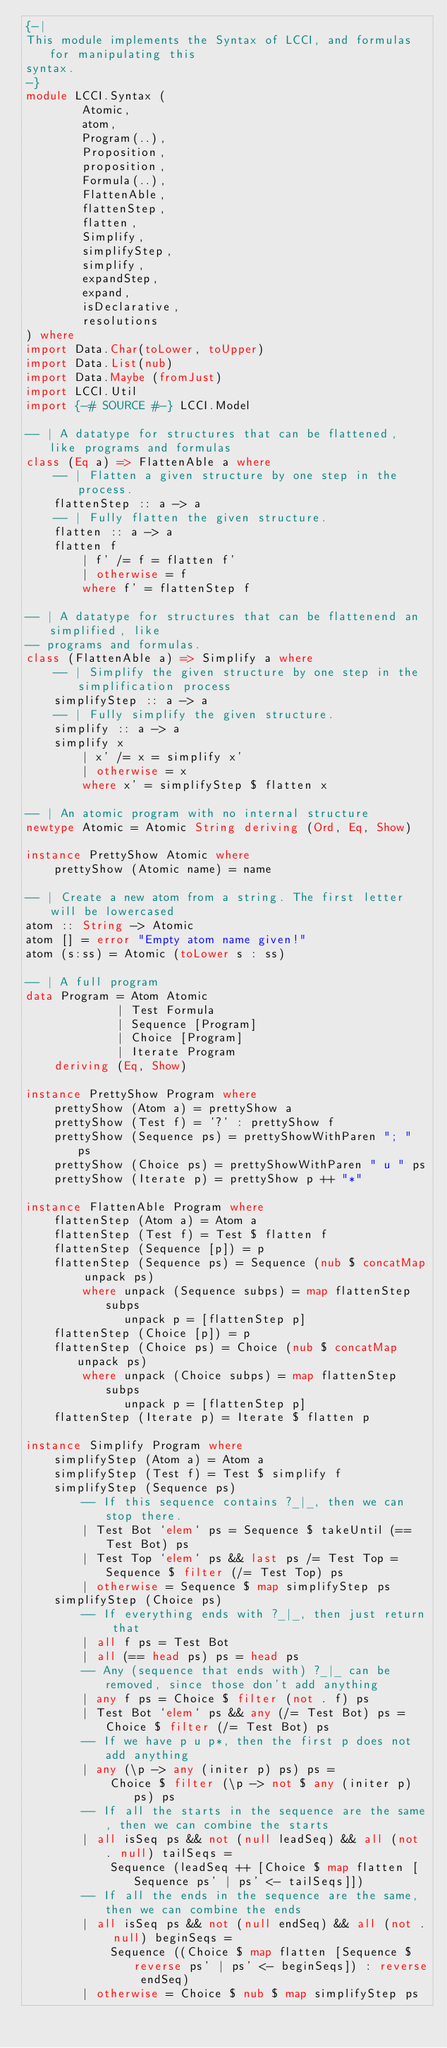Convert code to text. <code><loc_0><loc_0><loc_500><loc_500><_Haskell_>{-|
This module implements the Syntax of LCCI, and formulas for manipulating this
syntax.
-}
module LCCI.Syntax (
        Atomic,
        atom,
        Program(..),
        Proposition,
        proposition,
        Formula(..),
        FlattenAble,
        flattenStep,
        flatten,
        Simplify,
        simplifyStep,
        simplify,
        expandStep,
        expand,
        isDeclarative,
        resolutions
) where
import Data.Char(toLower, toUpper)
import Data.List(nub)
import Data.Maybe (fromJust)
import LCCI.Util
import {-# SOURCE #-} LCCI.Model

-- | A datatype for structures that can be flattened, like programs and formulas
class (Eq a) => FlattenAble a where
    -- | Flatten a given structure by one step in the process.
    flattenStep :: a -> a
    -- | Fully flatten the given structure.
    flatten :: a -> a
    flatten f
        | f' /= f = flatten f'
        | otherwise = f
        where f' = flattenStep f

-- | A datatype for structures that can be flattenend an simplified, like
-- programs and formulas.
class (FlattenAble a) => Simplify a where
    -- | Simplify the given structure by one step in the simplification process
    simplifyStep :: a -> a
    -- | Fully simplify the given structure.
    simplify :: a -> a
    simplify x
        | x' /= x = simplify x'
        | otherwise = x
        where x' = simplifyStep $ flatten x

-- | An atomic program with no internal structure
newtype Atomic = Atomic String deriving (Ord, Eq, Show)

instance PrettyShow Atomic where
    prettyShow (Atomic name) = name

-- | Create a new atom from a string. The first letter will be lowercased
atom :: String -> Atomic
atom [] = error "Empty atom name given!"
atom (s:ss) = Atomic (toLower s : ss)

-- | A full program
data Program = Atom Atomic
             | Test Formula
             | Sequence [Program]
             | Choice [Program]
             | Iterate Program
    deriving (Eq, Show)

instance PrettyShow Program where
    prettyShow (Atom a) = prettyShow a
    prettyShow (Test f) = '?' : prettyShow f
    prettyShow (Sequence ps) = prettyShowWithParen "; " ps
    prettyShow (Choice ps) = prettyShowWithParen " u " ps
    prettyShow (Iterate p) = prettyShow p ++ "*"

instance FlattenAble Program where
    flattenStep (Atom a) = Atom a
    flattenStep (Test f) = Test $ flatten f
    flattenStep (Sequence [p]) = p
    flattenStep (Sequence ps) = Sequence (nub $ concatMap unpack ps)
        where unpack (Sequence subps) = map flattenStep subps
              unpack p = [flattenStep p]
    flattenStep (Choice [p]) = p
    flattenStep (Choice ps) = Choice (nub $ concatMap unpack ps)
        where unpack (Choice subps) = map flattenStep subps
              unpack p = [flattenStep p]
    flattenStep (Iterate p) = Iterate $ flatten p

instance Simplify Program where
    simplifyStep (Atom a) = Atom a
    simplifyStep (Test f) = Test $ simplify f
    simplifyStep (Sequence ps)
        -- If this sequence contains ?_|_, then we can stop there.
        | Test Bot `elem` ps = Sequence $ takeUntil (== Test Bot) ps
        | Test Top `elem` ps && last ps /= Test Top = Sequence $ filter (/= Test Top) ps
        | otherwise = Sequence $ map simplifyStep ps
    simplifyStep (Choice ps)
        -- If everything ends with ?_|_, then just return that
        | all f ps = Test Bot
        | all (== head ps) ps = head ps
        -- Any (sequence that ends with) ?_|_ can be removed, since those don't add anything
        | any f ps = Choice $ filter (not . f) ps
        | Test Bot `elem` ps && any (/= Test Bot) ps = Choice $ filter (/= Test Bot) ps
        -- If we have p u p*, then the first p does not add anything
        | any (\p -> any (initer p) ps) ps =
            Choice $ filter (\p -> not $ any (initer p) ps) ps
        -- If all the starts in the sequence are the same, then we can combine the starts
        | all isSeq ps && not (null leadSeq) && all (not . null) tailSeqs =
            Sequence (leadSeq ++ [Choice $ map flatten [Sequence ps' | ps' <- tailSeqs]])
        -- If all the ends in the sequence are the same, then we can combine the ends
        | all isSeq ps && not (null endSeq) && all (not . null) beginSeqs =
            Sequence ((Choice $ map flatten [Sequence $ reverse ps' | ps' <- beginSeqs]) : reverse endSeq)
        | otherwise = Choice $ nub $ map simplifyStep ps</code> 